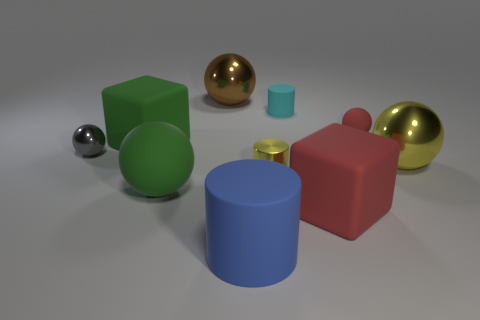Subtract all yellow balls. How many balls are left? 4 Subtract all small shiny spheres. How many spheres are left? 4 Subtract all cyan balls. Subtract all red cylinders. How many balls are left? 5 Subtract all cubes. How many objects are left? 8 Add 2 metallic objects. How many metallic objects exist? 6 Subtract 1 green blocks. How many objects are left? 9 Subtract all big brown things. Subtract all tiny objects. How many objects are left? 5 Add 6 small metal cylinders. How many small metal cylinders are left? 7 